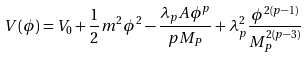Convert formula to latex. <formula><loc_0><loc_0><loc_500><loc_500>V ( \phi ) = V _ { 0 } + \frac { 1 } { 2 } m ^ { 2 } \phi ^ { 2 } - \frac { \lambda _ { p } A \phi ^ { p } } { p M _ { P } } + \lambda _ { p } ^ { 2 } \frac { \phi ^ { 2 ( p - 1 ) } } { M _ { P } ^ { 2 ( p - 3 ) } }</formula> 